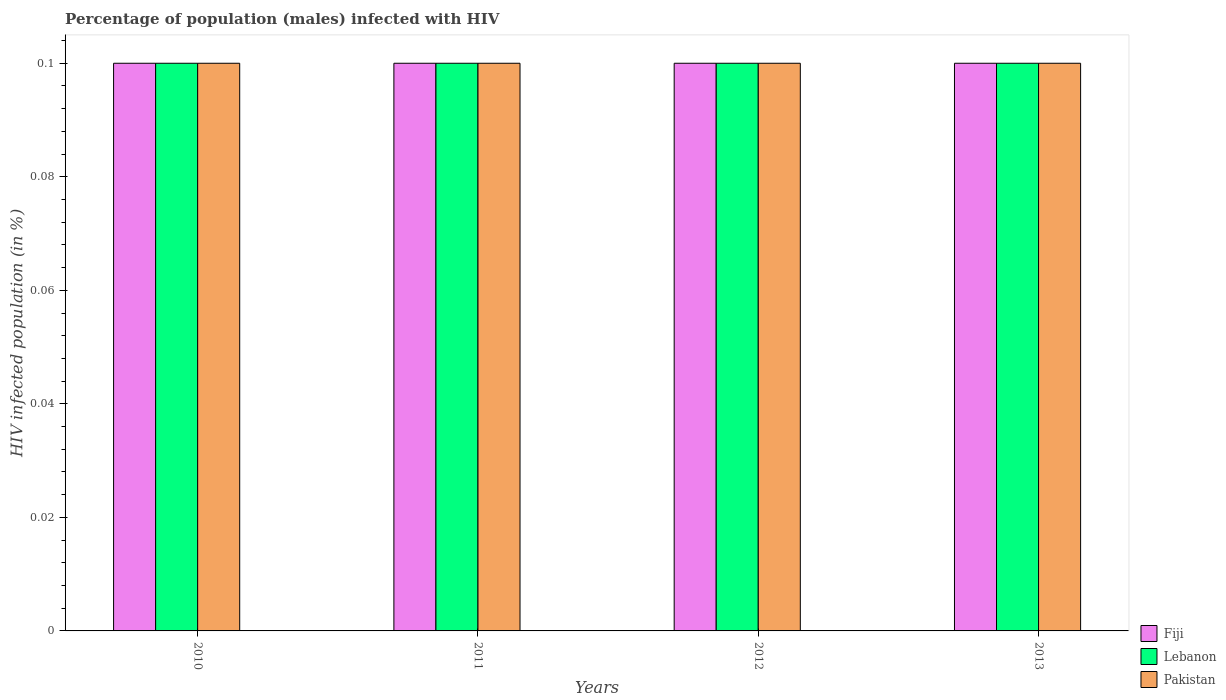Are the number of bars per tick equal to the number of legend labels?
Make the answer very short. Yes. Are the number of bars on each tick of the X-axis equal?
Your answer should be very brief. Yes. How many bars are there on the 2nd tick from the left?
Ensure brevity in your answer.  3. How many bars are there on the 4th tick from the right?
Ensure brevity in your answer.  3. Across all years, what is the maximum percentage of HIV infected male population in Lebanon?
Your response must be concise. 0.1. In which year was the percentage of HIV infected male population in Lebanon maximum?
Ensure brevity in your answer.  2010. What is the difference between the percentage of HIV infected male population in Fiji in 2010 and that in 2013?
Offer a very short reply. 0. What is the difference between the percentage of HIV infected male population in Pakistan in 2011 and the percentage of HIV infected male population in Lebanon in 2012?
Your answer should be compact. 0. What is the average percentage of HIV infected male population in Pakistan per year?
Offer a terse response. 0.1. In the year 2012, what is the difference between the percentage of HIV infected male population in Fiji and percentage of HIV infected male population in Pakistan?
Your answer should be compact. 0. What is the ratio of the percentage of HIV infected male population in Pakistan in 2011 to that in 2012?
Your answer should be very brief. 1. Is the percentage of HIV infected male population in Pakistan in 2011 less than that in 2013?
Offer a very short reply. No. Is the difference between the percentage of HIV infected male population in Fiji in 2012 and 2013 greater than the difference between the percentage of HIV infected male population in Pakistan in 2012 and 2013?
Provide a short and direct response. No. What is the difference between the highest and the lowest percentage of HIV infected male population in Pakistan?
Offer a very short reply. 0. In how many years, is the percentage of HIV infected male population in Pakistan greater than the average percentage of HIV infected male population in Pakistan taken over all years?
Your response must be concise. 0. Is the sum of the percentage of HIV infected male population in Fiji in 2010 and 2012 greater than the maximum percentage of HIV infected male population in Lebanon across all years?
Your answer should be compact. Yes. What does the 1st bar from the left in 2010 represents?
Provide a succinct answer. Fiji. How many years are there in the graph?
Your response must be concise. 4. Are the values on the major ticks of Y-axis written in scientific E-notation?
Provide a succinct answer. No. Where does the legend appear in the graph?
Offer a terse response. Bottom right. How many legend labels are there?
Provide a succinct answer. 3. What is the title of the graph?
Make the answer very short. Percentage of population (males) infected with HIV. Does "High income: OECD" appear as one of the legend labels in the graph?
Provide a succinct answer. No. What is the label or title of the Y-axis?
Offer a very short reply. HIV infected population (in %). What is the HIV infected population (in %) of Fiji in 2010?
Your response must be concise. 0.1. What is the HIV infected population (in %) in Lebanon in 2010?
Provide a short and direct response. 0.1. What is the HIV infected population (in %) of Pakistan in 2010?
Offer a terse response. 0.1. What is the HIV infected population (in %) in Fiji in 2011?
Give a very brief answer. 0.1. What is the HIV infected population (in %) in Lebanon in 2011?
Offer a very short reply. 0.1. What is the HIV infected population (in %) of Pakistan in 2011?
Provide a succinct answer. 0.1. What is the HIV infected population (in %) of Fiji in 2012?
Give a very brief answer. 0.1. What is the HIV infected population (in %) in Fiji in 2013?
Your answer should be compact. 0.1. What is the HIV infected population (in %) of Lebanon in 2013?
Ensure brevity in your answer.  0.1. What is the HIV infected population (in %) in Pakistan in 2013?
Your answer should be compact. 0.1. Across all years, what is the maximum HIV infected population (in %) of Fiji?
Make the answer very short. 0.1. Across all years, what is the minimum HIV infected population (in %) of Lebanon?
Provide a succinct answer. 0.1. What is the total HIV infected population (in %) of Lebanon in the graph?
Your response must be concise. 0.4. What is the difference between the HIV infected population (in %) in Fiji in 2010 and that in 2011?
Your response must be concise. 0. What is the difference between the HIV infected population (in %) of Pakistan in 2010 and that in 2011?
Offer a very short reply. 0. What is the difference between the HIV infected population (in %) of Fiji in 2010 and that in 2012?
Offer a terse response. 0. What is the difference between the HIV infected population (in %) in Lebanon in 2010 and that in 2013?
Provide a succinct answer. 0. What is the difference between the HIV infected population (in %) of Lebanon in 2011 and that in 2012?
Your response must be concise. 0. What is the difference between the HIV infected population (in %) in Pakistan in 2011 and that in 2012?
Give a very brief answer. 0. What is the difference between the HIV infected population (in %) of Fiji in 2011 and that in 2013?
Offer a very short reply. 0. What is the difference between the HIV infected population (in %) of Fiji in 2012 and that in 2013?
Your answer should be very brief. 0. What is the difference between the HIV infected population (in %) of Lebanon in 2012 and that in 2013?
Your response must be concise. 0. What is the difference between the HIV infected population (in %) in Pakistan in 2012 and that in 2013?
Ensure brevity in your answer.  0. What is the difference between the HIV infected population (in %) in Lebanon in 2010 and the HIV infected population (in %) in Pakistan in 2011?
Give a very brief answer. 0. What is the difference between the HIV infected population (in %) of Fiji in 2010 and the HIV infected population (in %) of Lebanon in 2013?
Provide a succinct answer. 0. What is the difference between the HIV infected population (in %) of Fiji in 2010 and the HIV infected population (in %) of Pakistan in 2013?
Give a very brief answer. 0. What is the difference between the HIV infected population (in %) of Lebanon in 2010 and the HIV infected population (in %) of Pakistan in 2013?
Your answer should be very brief. 0. What is the difference between the HIV infected population (in %) in Fiji in 2011 and the HIV infected population (in %) in Lebanon in 2012?
Your answer should be compact. 0. What is the difference between the HIV infected population (in %) of Fiji in 2011 and the HIV infected population (in %) of Pakistan in 2012?
Offer a very short reply. 0. What is the difference between the HIV infected population (in %) in Lebanon in 2011 and the HIV infected population (in %) in Pakistan in 2012?
Your response must be concise. 0. What is the difference between the HIV infected population (in %) in Fiji in 2011 and the HIV infected population (in %) in Lebanon in 2013?
Make the answer very short. 0. What is the difference between the HIV infected population (in %) of Fiji in 2012 and the HIV infected population (in %) of Pakistan in 2013?
Ensure brevity in your answer.  0. What is the average HIV infected population (in %) of Lebanon per year?
Give a very brief answer. 0.1. In the year 2010, what is the difference between the HIV infected population (in %) in Lebanon and HIV infected population (in %) in Pakistan?
Offer a terse response. 0. In the year 2012, what is the difference between the HIV infected population (in %) of Lebanon and HIV infected population (in %) of Pakistan?
Keep it short and to the point. 0. In the year 2013, what is the difference between the HIV infected population (in %) in Fiji and HIV infected population (in %) in Lebanon?
Your answer should be compact. 0. What is the ratio of the HIV infected population (in %) in Fiji in 2010 to that in 2011?
Your answer should be compact. 1. What is the ratio of the HIV infected population (in %) of Pakistan in 2010 to that in 2011?
Ensure brevity in your answer.  1. What is the ratio of the HIV infected population (in %) in Fiji in 2010 to that in 2013?
Offer a terse response. 1. What is the ratio of the HIV infected population (in %) of Lebanon in 2010 to that in 2013?
Make the answer very short. 1. What is the ratio of the HIV infected population (in %) in Fiji in 2011 to that in 2012?
Offer a very short reply. 1. What is the ratio of the HIV infected population (in %) in Lebanon in 2011 to that in 2012?
Provide a succinct answer. 1. What is the ratio of the HIV infected population (in %) in Pakistan in 2011 to that in 2012?
Ensure brevity in your answer.  1. What is the ratio of the HIV infected population (in %) of Lebanon in 2011 to that in 2013?
Ensure brevity in your answer.  1. What is the ratio of the HIV infected population (in %) in Fiji in 2012 to that in 2013?
Keep it short and to the point. 1. What is the ratio of the HIV infected population (in %) of Pakistan in 2012 to that in 2013?
Offer a terse response. 1. What is the difference between the highest and the second highest HIV infected population (in %) in Fiji?
Your answer should be compact. 0. What is the difference between the highest and the second highest HIV infected population (in %) in Lebanon?
Provide a succinct answer. 0. What is the difference between the highest and the second highest HIV infected population (in %) in Pakistan?
Make the answer very short. 0. What is the difference between the highest and the lowest HIV infected population (in %) in Fiji?
Your response must be concise. 0. What is the difference between the highest and the lowest HIV infected population (in %) of Lebanon?
Offer a terse response. 0. What is the difference between the highest and the lowest HIV infected population (in %) in Pakistan?
Provide a short and direct response. 0. 